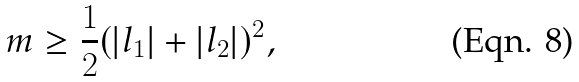Convert formula to latex. <formula><loc_0><loc_0><loc_500><loc_500>m \geq \frac { 1 } { 2 } ( | l _ { 1 } | + | l _ { 2 } | ) ^ { 2 } ,</formula> 